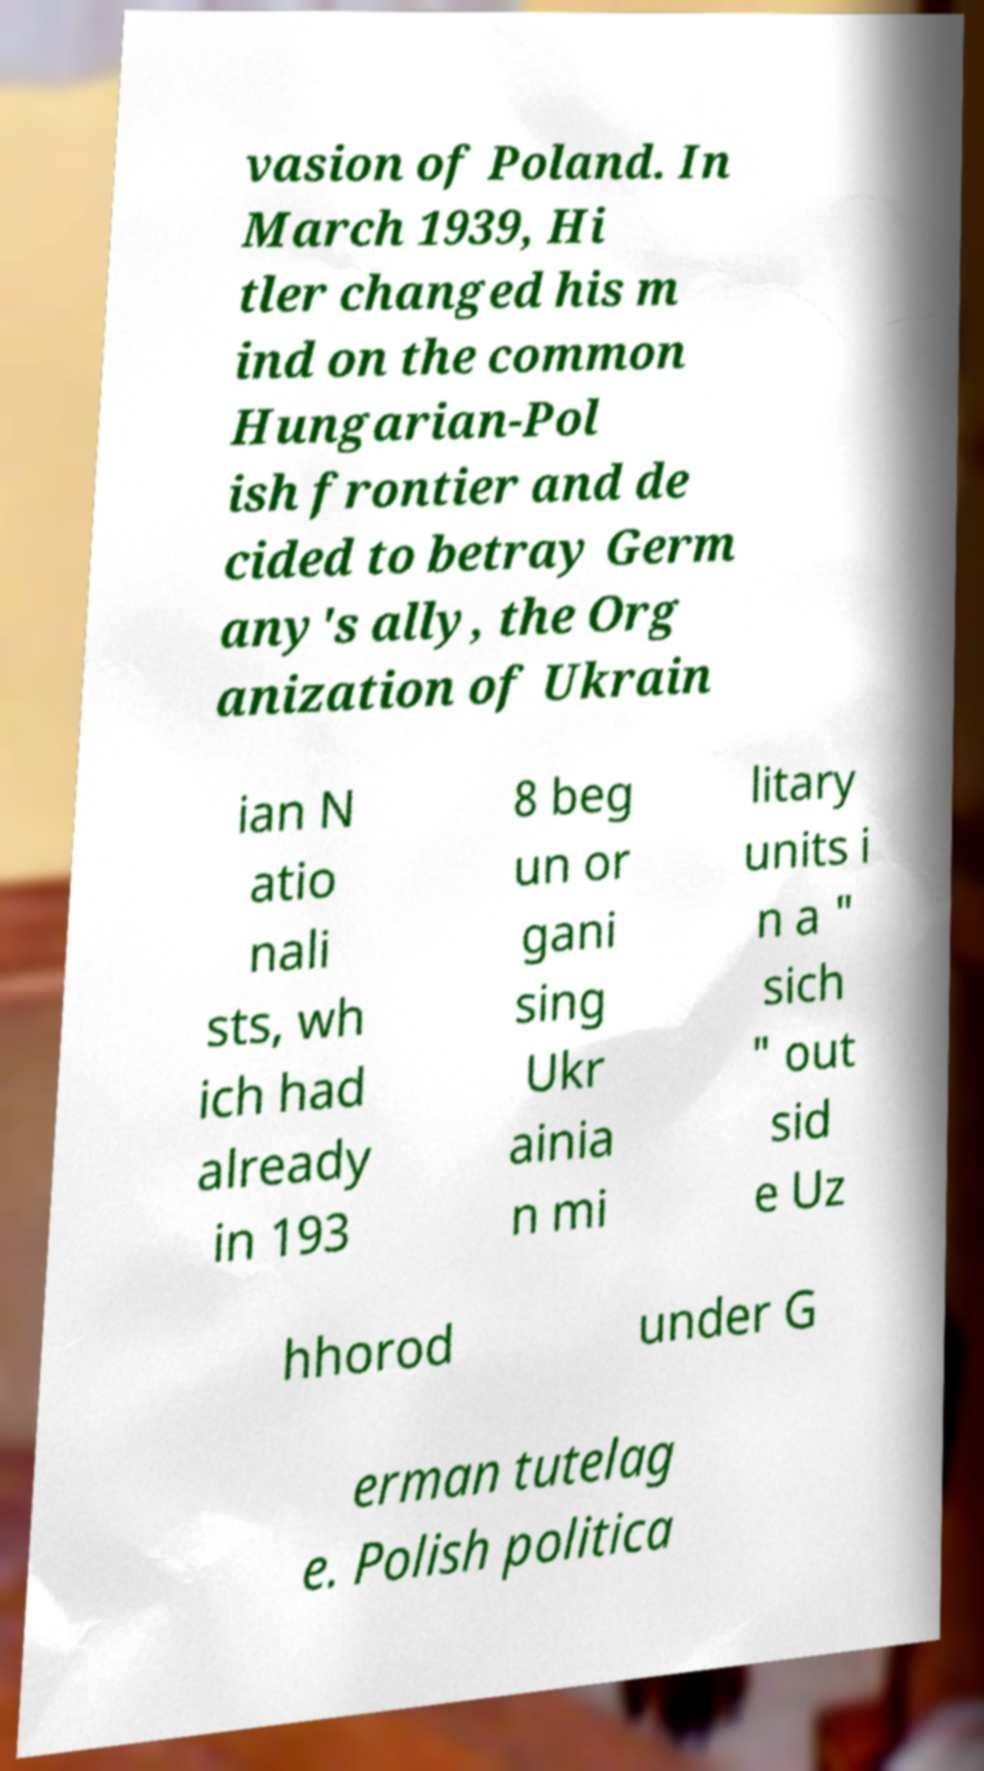Could you assist in decoding the text presented in this image and type it out clearly? vasion of Poland. In March 1939, Hi tler changed his m ind on the common Hungarian-Pol ish frontier and de cided to betray Germ any's ally, the Org anization of Ukrain ian N atio nali sts, wh ich had already in 193 8 beg un or gani sing Ukr ainia n mi litary units i n a " sich " out sid e Uz hhorod under G erman tutelag e. Polish politica 